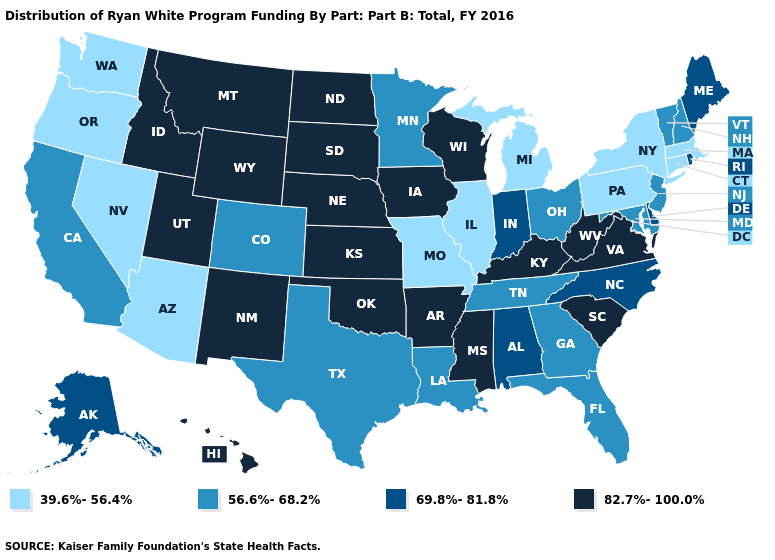Among the states that border Wisconsin , does Michigan have the highest value?
Give a very brief answer. No. Which states hav the highest value in the South?
Keep it brief. Arkansas, Kentucky, Mississippi, Oklahoma, South Carolina, Virginia, West Virginia. What is the highest value in the West ?
Answer briefly. 82.7%-100.0%. What is the lowest value in states that border Montana?
Keep it brief. 82.7%-100.0%. What is the value of Kansas?
Be succinct. 82.7%-100.0%. Name the states that have a value in the range 82.7%-100.0%?
Concise answer only. Arkansas, Hawaii, Idaho, Iowa, Kansas, Kentucky, Mississippi, Montana, Nebraska, New Mexico, North Dakota, Oklahoma, South Carolina, South Dakota, Utah, Virginia, West Virginia, Wisconsin, Wyoming. What is the highest value in the USA?
Keep it brief. 82.7%-100.0%. Name the states that have a value in the range 39.6%-56.4%?
Short answer required. Arizona, Connecticut, Illinois, Massachusetts, Michigan, Missouri, Nevada, New York, Oregon, Pennsylvania, Washington. What is the value of Georgia?
Write a very short answer. 56.6%-68.2%. What is the value of Rhode Island?
Quick response, please. 69.8%-81.8%. What is the value of Ohio?
Keep it brief. 56.6%-68.2%. Name the states that have a value in the range 39.6%-56.4%?
Answer briefly. Arizona, Connecticut, Illinois, Massachusetts, Michigan, Missouri, Nevada, New York, Oregon, Pennsylvania, Washington. What is the lowest value in the MidWest?
Give a very brief answer. 39.6%-56.4%. What is the lowest value in the USA?
Be succinct. 39.6%-56.4%. 